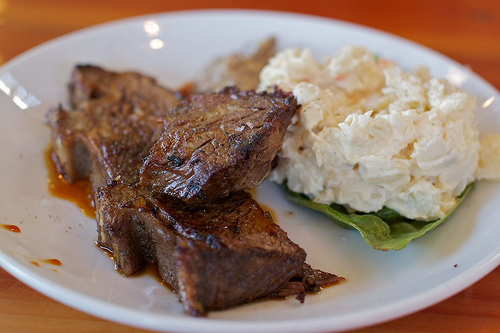<image>
Can you confirm if the meat is next to the table? No. The meat is not positioned next to the table. They are located in different areas of the scene. 